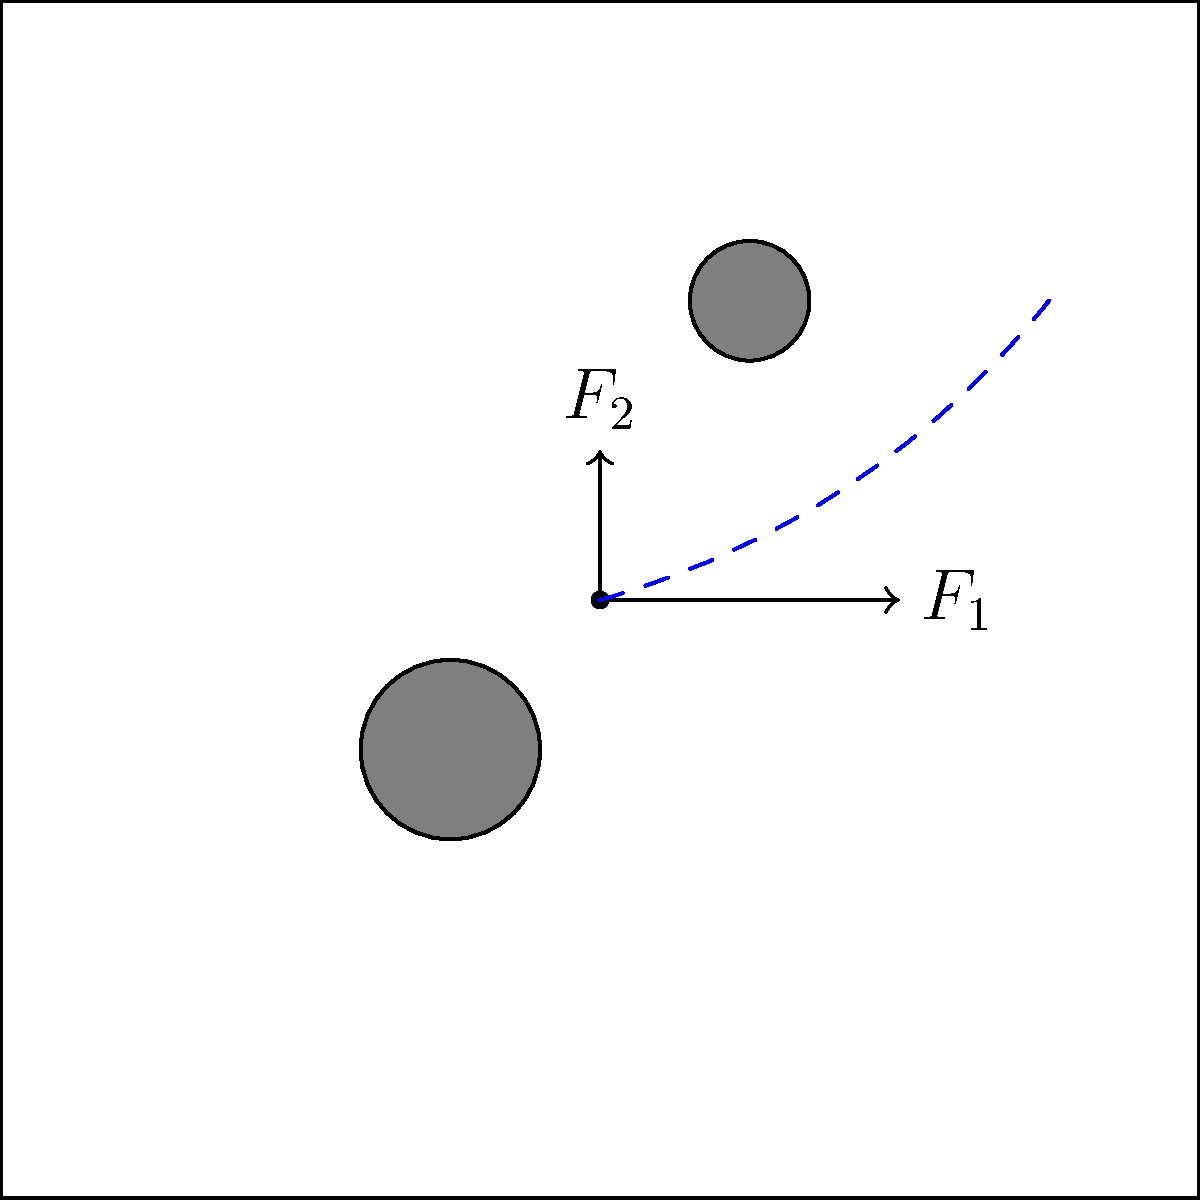Given the diagram showing a playing field with two circular obstacles and two force vectors ($F_1$ and $F_2$) acting on a ball at the origin, predict the most likely path of the ball. Which of the following best describes the ball's trajectory?

A) Straight line towards the upper right corner
B) Curved path avoiding both obstacles
C) Deflection off the first obstacle
D) Straight line following $F_1$ To predict the ball's path, we need to consider the following factors:

1. Initial forces: 
   - $F_1$ is stronger and points horizontally to the right
   - $F_2$ is weaker and points vertically upward

2. Resultant force: The combination of $F_1$ and $F_2$ will create a resultant force directed towards the upper right, but with a stronger rightward component.

3. Obstacles:
   - There's a small obstacle at (0.5, 1)
   - There's a larger obstacle at (-0.5, -0.5)

4. Trajectory analysis:
   - The ball will initially move in the direction of the resultant force (upper right)
   - It will need to avoid the small obstacle at (0.5, 1)
   - The larger obstacle at (-0.5, -0.5) won't affect the path directly

5. Path prediction:
   - The ball will likely follow a curved path
   - It will start moving towards the upper right
   - The path will curve to avoid the small obstacle
   - After passing the obstacle, it will continue its upward and rightward movement

Given these considerations, the most likely path for the ball is a curved trajectory that avoids both obstacles while generally moving towards the upper right corner of the field.
Answer: B 